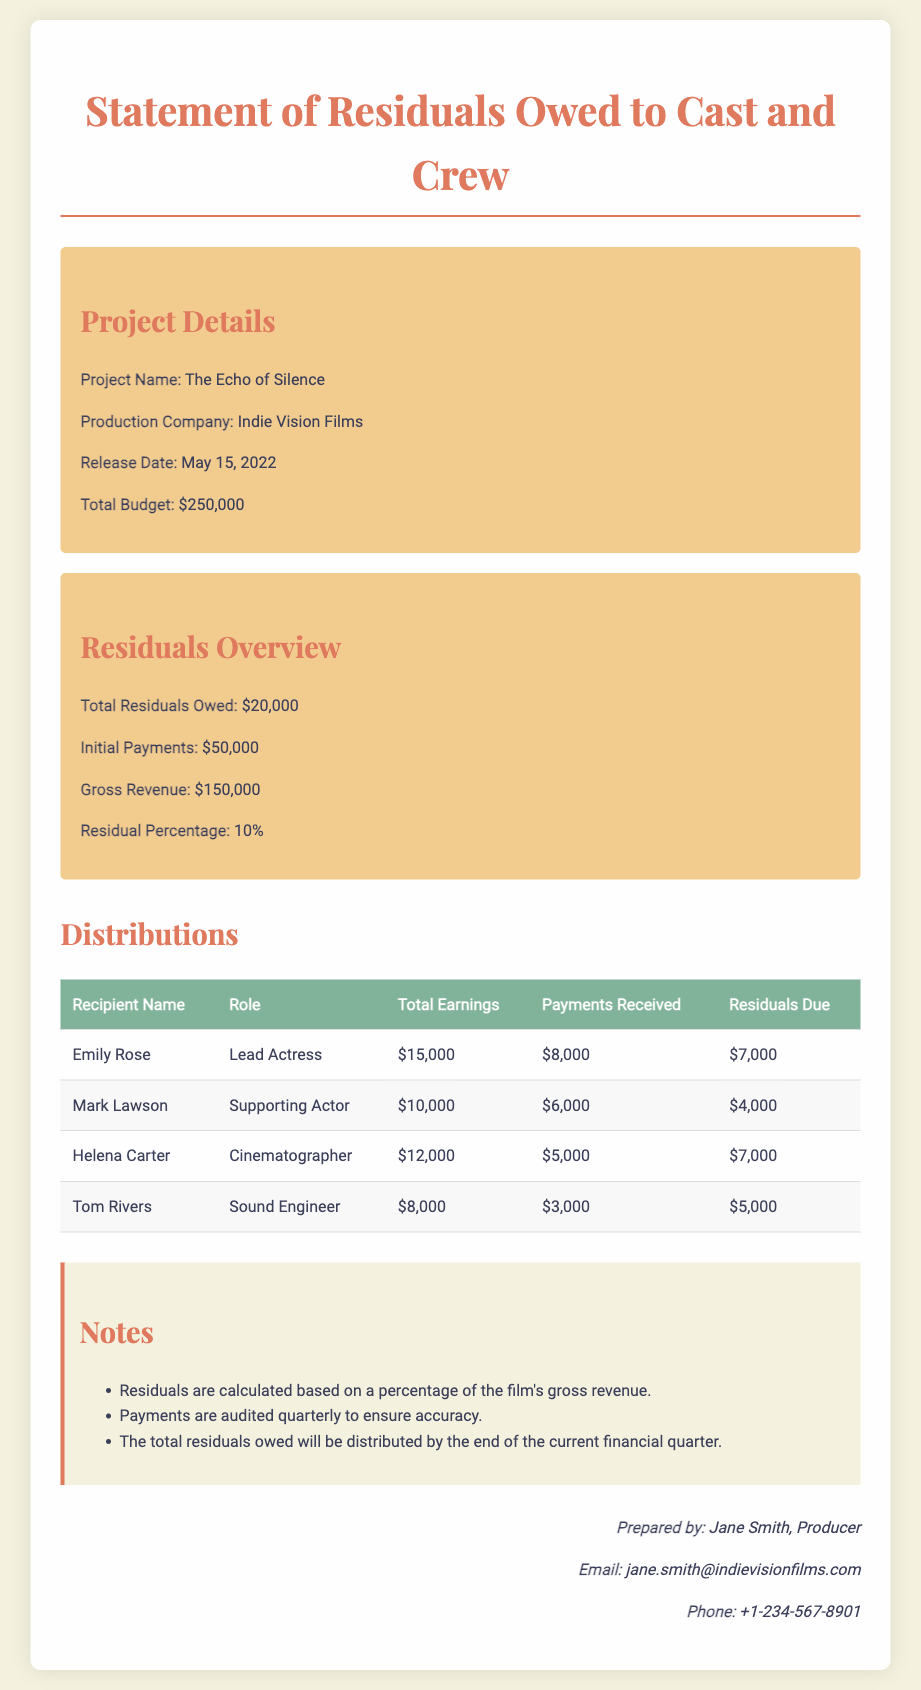What is the project name? The project name is specified in the project details section of the document.
Answer: The Echo of Silence Who prepared the document? The prepared by section identifies the individual responsible for this statement.
Answer: Jane Smith What is the total budget for the project? The total budget is outlined in the project details section.
Answer: $250,000 How much are total residuals owed? The total residuals owed are stated in the residuals overview section.
Answer: $20,000 What percentage is used to calculate residuals? The residual percentage is specified in the residuals overview section.
Answer: 10% Who is the lead actress in the project? The table lists the cast and crew members and their roles.
Answer: Emily Rose How much has Mark Lawson received in payments? Payments received for each recipient are detailed in the distribution table.
Answer: $6,000 What is the gross revenue of the project? The gross revenue is provided in the residuals overview section.
Answer: $150,000 How much are the residuals due for the sound engineer? The residuals due for each recipient are detailed in the distribution table.
Answer: $5,000 